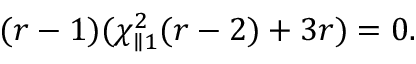<formula> <loc_0><loc_0><loc_500><loc_500>( r - 1 ) ( \chi _ { \| 1 } ^ { 2 } ( r - 2 ) + 3 r ) = 0 .</formula> 